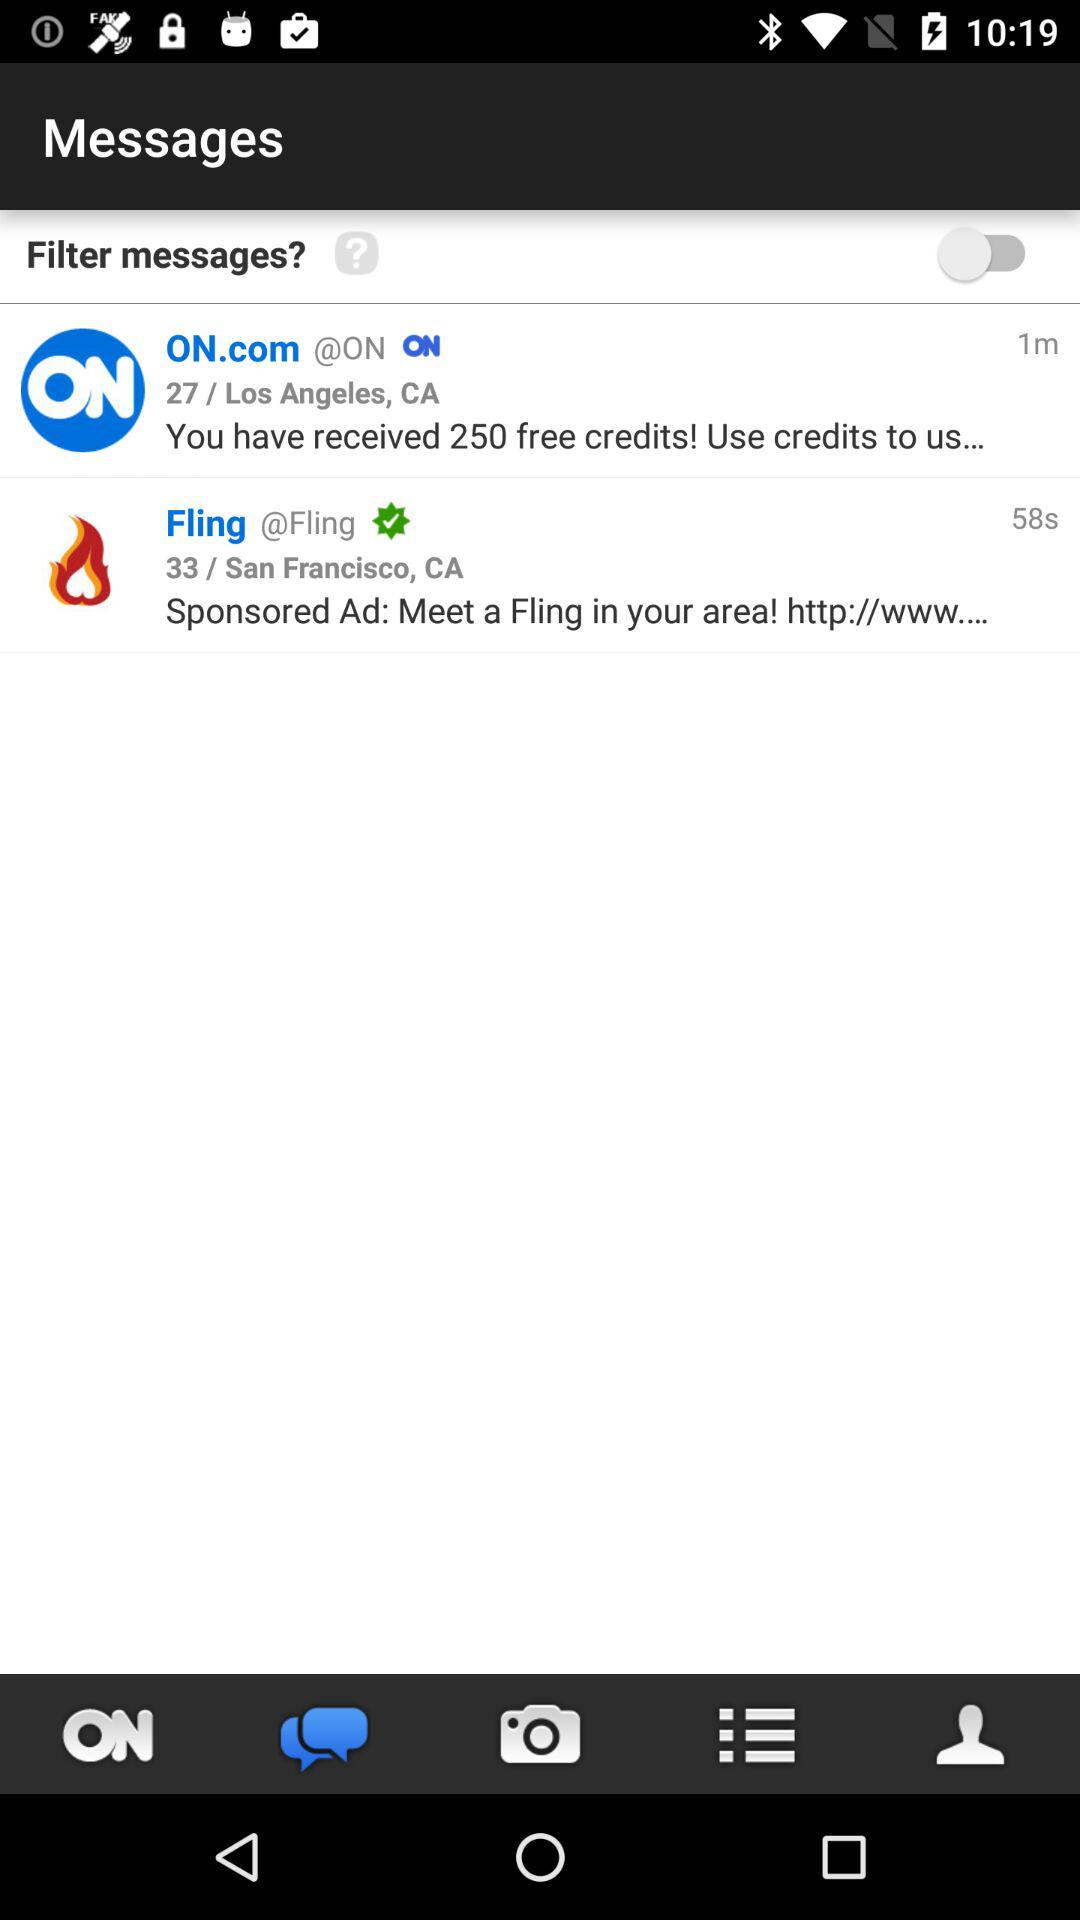How many more messages have been received from ON.com than Fling?
Answer the question using a single word or phrase. 1 